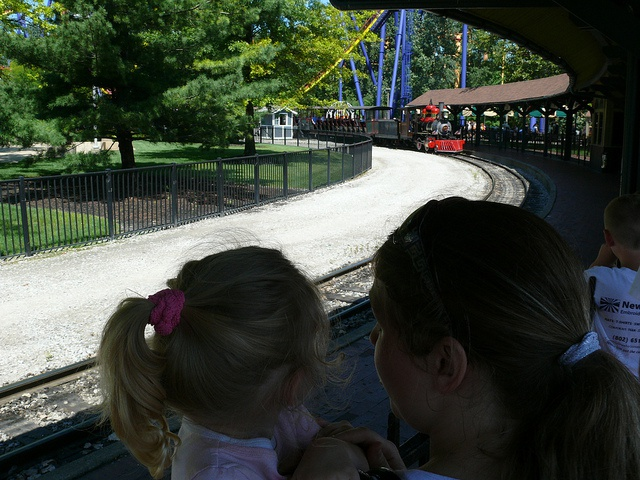Describe the objects in this image and their specific colors. I can see people in khaki, black, navy, darkblue, and gray tones, people in khaki, black, gray, and darkblue tones, people in khaki, black, darkblue, blue, and navy tones, train in khaki, black, gray, maroon, and darkgray tones, and people in khaki, black, brown, maroon, and olive tones in this image. 